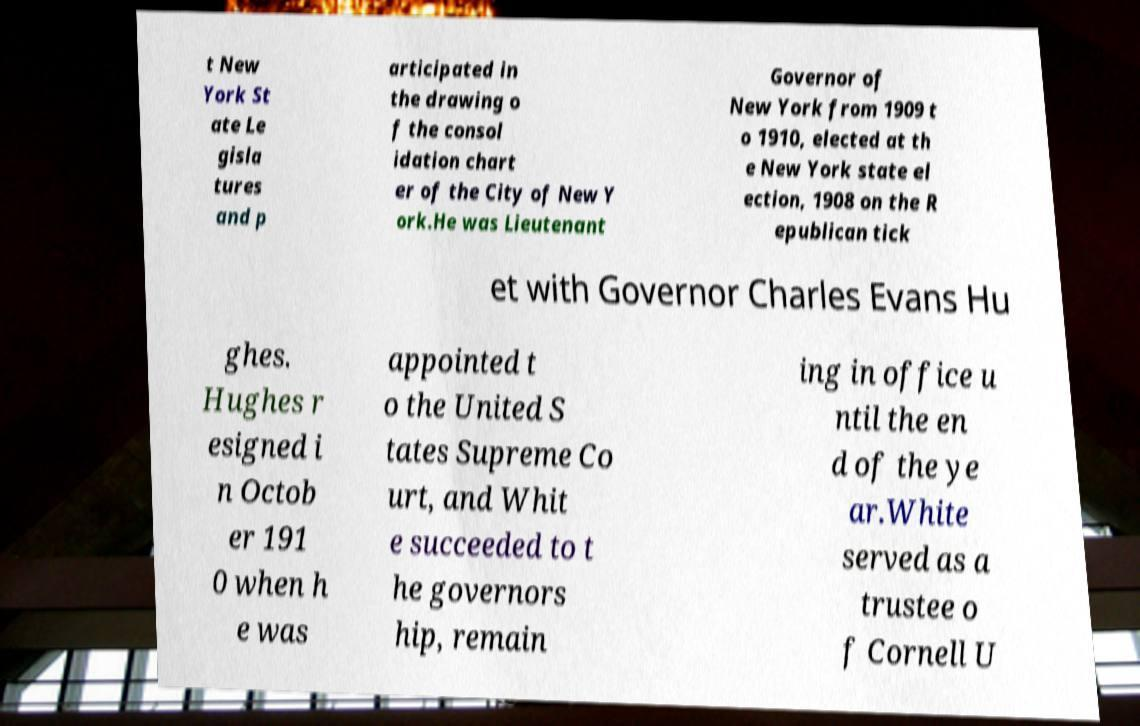For documentation purposes, I need the text within this image transcribed. Could you provide that? t New York St ate Le gisla tures and p articipated in the drawing o f the consol idation chart er of the City of New Y ork.He was Lieutenant Governor of New York from 1909 t o 1910, elected at th e New York state el ection, 1908 on the R epublican tick et with Governor Charles Evans Hu ghes. Hughes r esigned i n Octob er 191 0 when h e was appointed t o the United S tates Supreme Co urt, and Whit e succeeded to t he governors hip, remain ing in office u ntil the en d of the ye ar.White served as a trustee o f Cornell U 